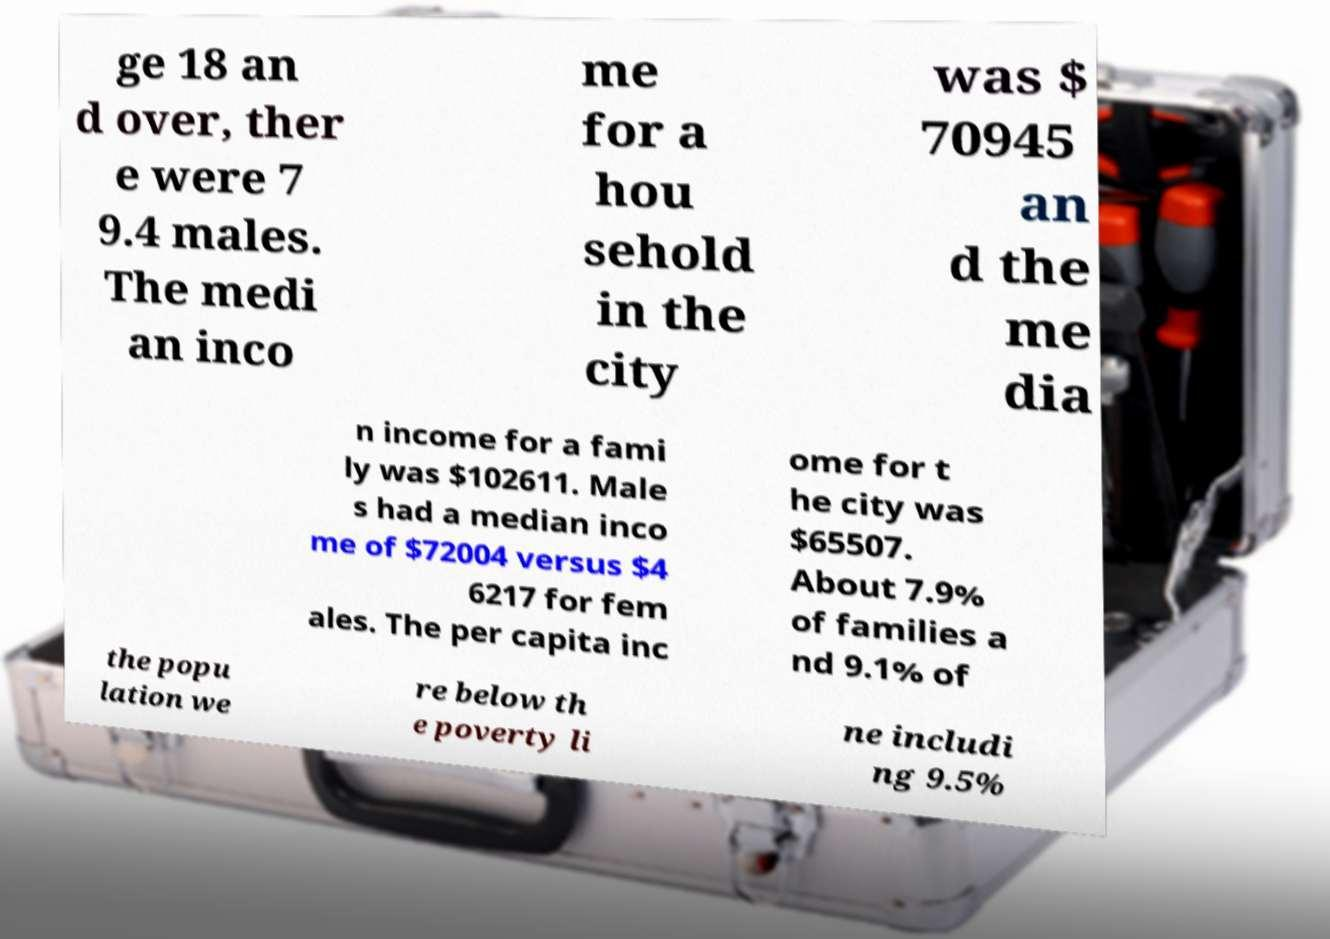Can you read and provide the text displayed in the image?This photo seems to have some interesting text. Can you extract and type it out for me? ge 18 an d over, ther e were 7 9.4 males. The medi an inco me for a hou sehold in the city was $ 70945 an d the me dia n income for a fami ly was $102611. Male s had a median inco me of $72004 versus $4 6217 for fem ales. The per capita inc ome for t he city was $65507. About 7.9% of families a nd 9.1% of the popu lation we re below th e poverty li ne includi ng 9.5% 